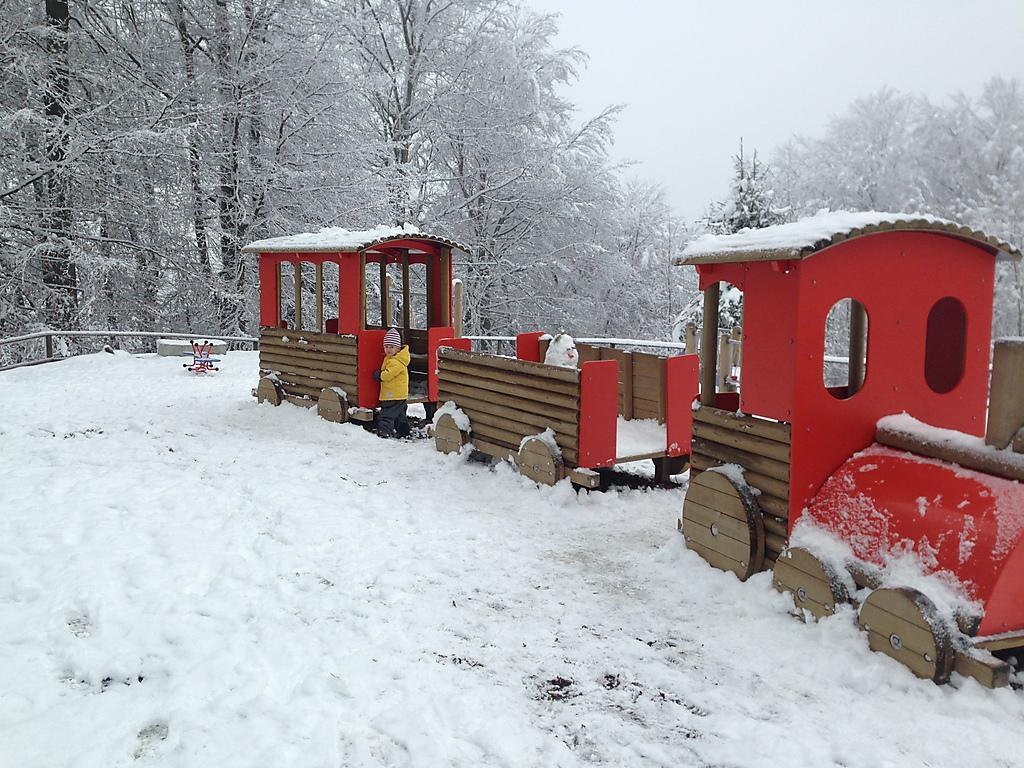What is located in the foreground of the picture? There is a wooden train and a cart in the foreground of the picture. Who is present in the foreground of the picture? There is a kid in the foreground of the picture. What is the ground made of in the foreground of the picture? There is snow in the foreground of the picture. What can be seen in the background of the picture? There are trees in the background of the picture. Where is the swing located in the image? There is no swing present in the image. What type of vest is the farmer wearing in the image? There is no farmer or vest present in the image. 